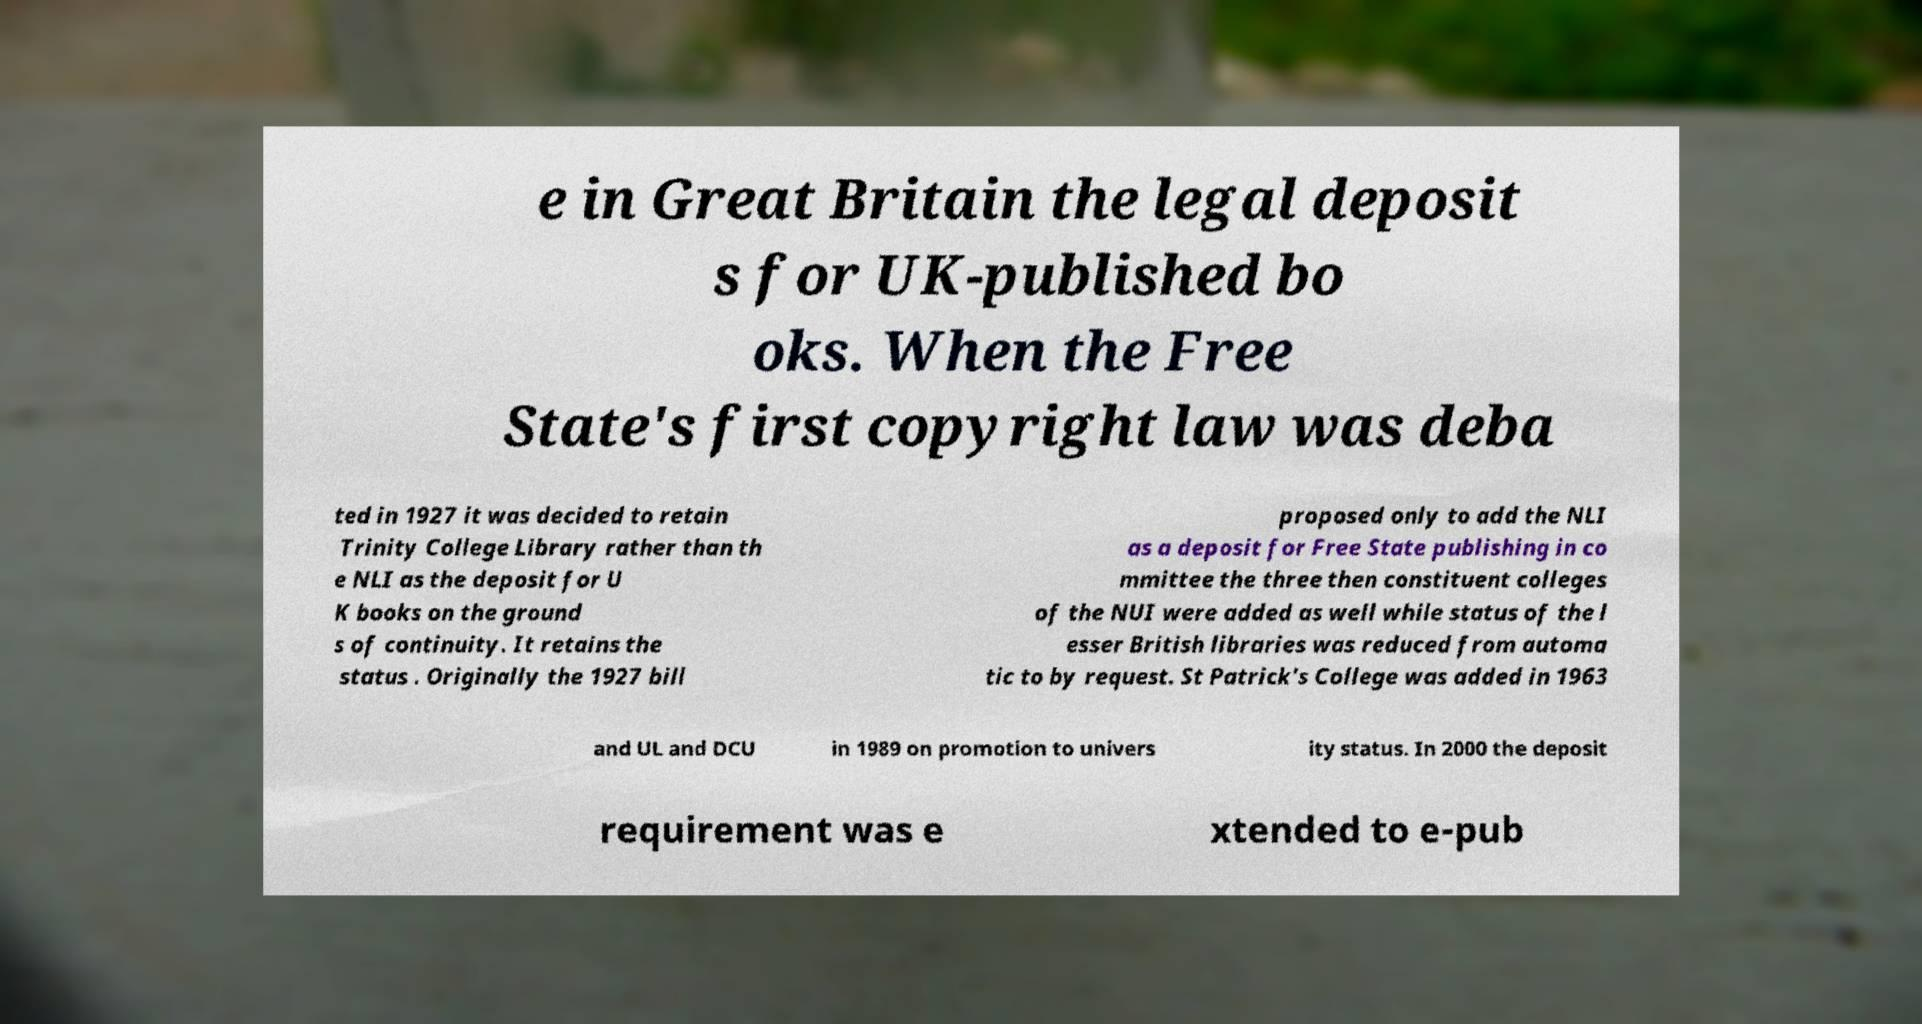Please read and relay the text visible in this image. What does it say? e in Great Britain the legal deposit s for UK-published bo oks. When the Free State's first copyright law was deba ted in 1927 it was decided to retain Trinity College Library rather than th e NLI as the deposit for U K books on the ground s of continuity. It retains the status . Originally the 1927 bill proposed only to add the NLI as a deposit for Free State publishing in co mmittee the three then constituent colleges of the NUI were added as well while status of the l esser British libraries was reduced from automa tic to by request. St Patrick's College was added in 1963 and UL and DCU in 1989 on promotion to univers ity status. In 2000 the deposit requirement was e xtended to e-pub 